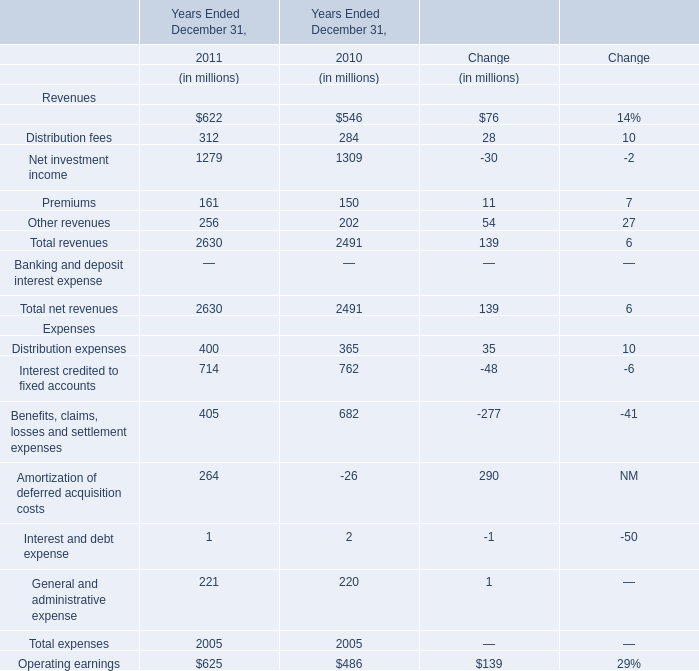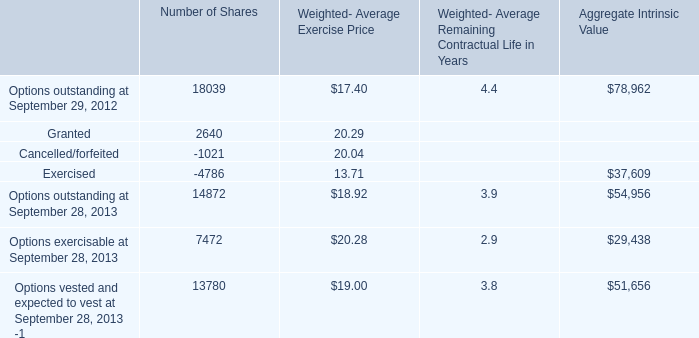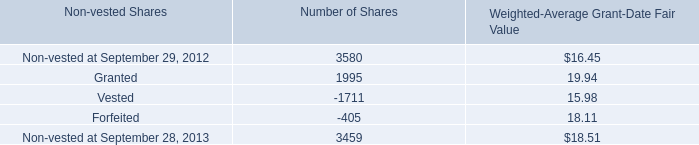What's the average of Exercised of Number of Shares, and Vested of Number of Shares ? 
Computations: ((4786.0 + 1711.0) / 2)
Answer: 3248.5. 